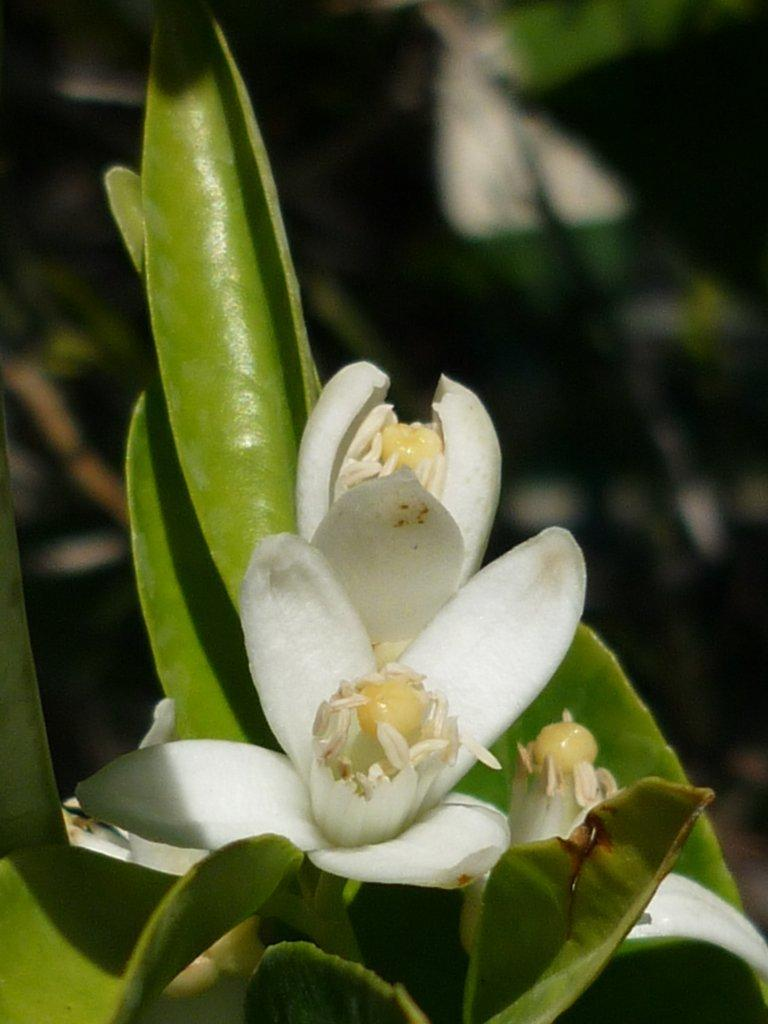What type of plants can be seen in the image? There are flowers and leaves in the image. Can you describe the appearance of the flowers and leaves? The flowers and leaves are clearly visible in the image. What is visible in the background of the image? There are objects in the background of the image, but they are blurry. What language is the monkey speaking in the image? There is no monkey present in the image, so it is not possible to determine what language it might be speaking. 